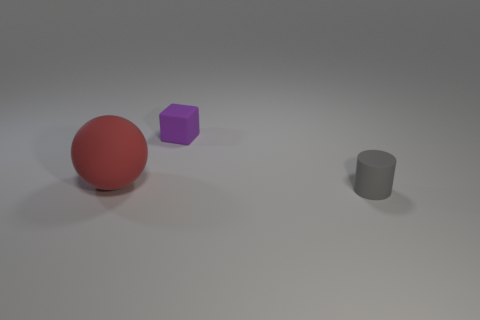Add 3 matte cubes. How many objects exist? 6 Subtract all balls. How many objects are left? 2 Subtract all big purple matte cubes. Subtract all big objects. How many objects are left? 2 Add 1 small blocks. How many small blocks are left? 2 Add 1 small matte things. How many small matte things exist? 3 Subtract 0 green spheres. How many objects are left? 3 